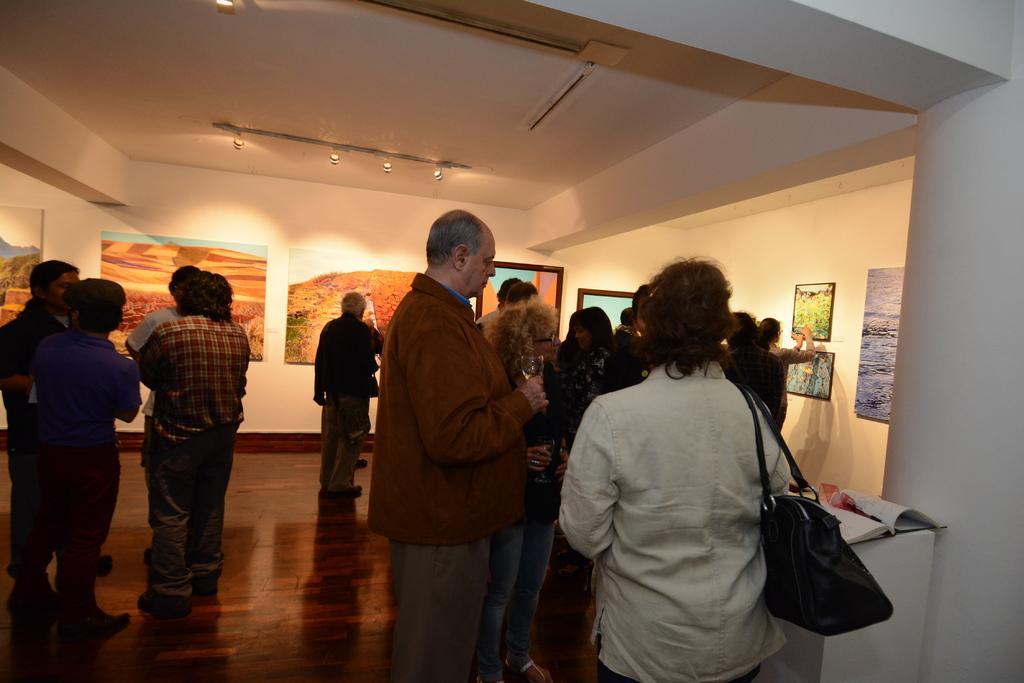In one or two sentences, can you explain what this image depicts? In the image few people are standing and holding something in their hands. Behind them there is a table, on the table there are some books. At the top of the image there is wall, on the wall there are some frames. 